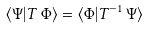Convert formula to latex. <formula><loc_0><loc_0><loc_500><loc_500>\langle \Psi | T \, \Phi \rangle = \langle \Phi | T ^ { - 1 } \, \Psi \rangle</formula> 